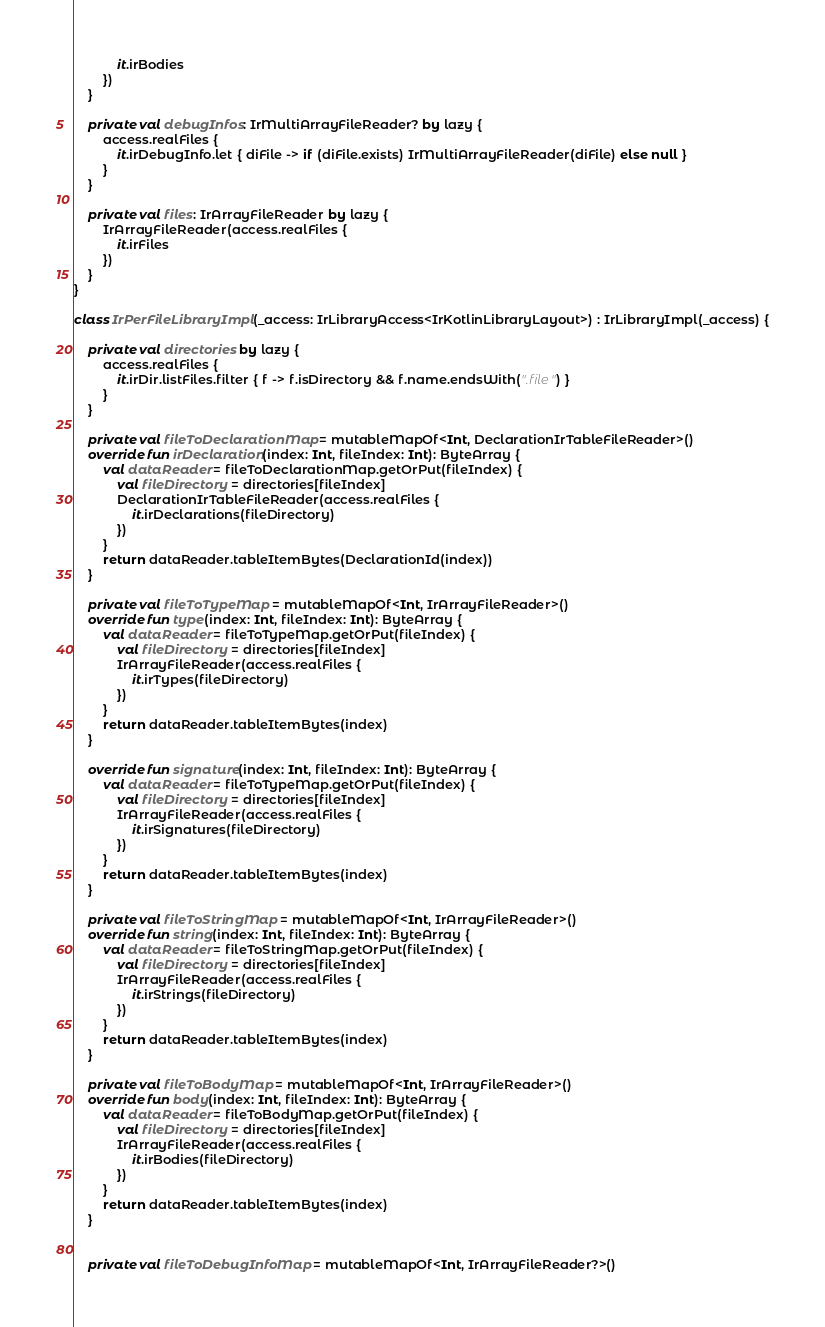Convert code to text. <code><loc_0><loc_0><loc_500><loc_500><_Kotlin_>            it.irBodies
        })
    }

    private val debugInfos: IrMultiArrayFileReader? by lazy {
        access.realFiles {
            it.irDebugInfo.let { diFile -> if (diFile.exists) IrMultiArrayFileReader(diFile) else null }
        }
    }

    private val files: IrArrayFileReader by lazy {
        IrArrayFileReader(access.realFiles {
            it.irFiles
        })
    }
}

class IrPerFileLibraryImpl(_access: IrLibraryAccess<IrKotlinLibraryLayout>) : IrLibraryImpl(_access) {

    private val directories by lazy {
        access.realFiles {
            it.irDir.listFiles.filter { f -> f.isDirectory && f.name.endsWith(".file") }
        }
    }

    private val fileToDeclarationMap = mutableMapOf<Int, DeclarationIrTableFileReader>()
    override fun irDeclaration(index: Int, fileIndex: Int): ByteArray {
        val dataReader = fileToDeclarationMap.getOrPut(fileIndex) {
            val fileDirectory = directories[fileIndex]
            DeclarationIrTableFileReader(access.realFiles {
                it.irDeclarations(fileDirectory)
            })
        }
        return dataReader.tableItemBytes(DeclarationId(index))
    }

    private val fileToTypeMap = mutableMapOf<Int, IrArrayFileReader>()
    override fun type(index: Int, fileIndex: Int): ByteArray {
        val dataReader = fileToTypeMap.getOrPut(fileIndex) {
            val fileDirectory = directories[fileIndex]
            IrArrayFileReader(access.realFiles {
                it.irTypes(fileDirectory)
            })
        }
        return dataReader.tableItemBytes(index)
    }

    override fun signature(index: Int, fileIndex: Int): ByteArray {
        val dataReader = fileToTypeMap.getOrPut(fileIndex) {
            val fileDirectory = directories[fileIndex]
            IrArrayFileReader(access.realFiles {
                it.irSignatures(fileDirectory)
            })
        }
        return dataReader.tableItemBytes(index)
    }

    private val fileToStringMap = mutableMapOf<Int, IrArrayFileReader>()
    override fun string(index: Int, fileIndex: Int): ByteArray {
        val dataReader = fileToStringMap.getOrPut(fileIndex) {
            val fileDirectory = directories[fileIndex]
            IrArrayFileReader(access.realFiles {
                it.irStrings(fileDirectory)
            })
        }
        return dataReader.tableItemBytes(index)
    }

    private val fileToBodyMap = mutableMapOf<Int, IrArrayFileReader>()
    override fun body(index: Int, fileIndex: Int): ByteArray {
        val dataReader = fileToBodyMap.getOrPut(fileIndex) {
            val fileDirectory = directories[fileIndex]
            IrArrayFileReader(access.realFiles {
                it.irBodies(fileDirectory)
            })
        }
        return dataReader.tableItemBytes(index)
    }


    private val fileToDebugInfoMap = mutableMapOf<Int, IrArrayFileReader?>()</code> 